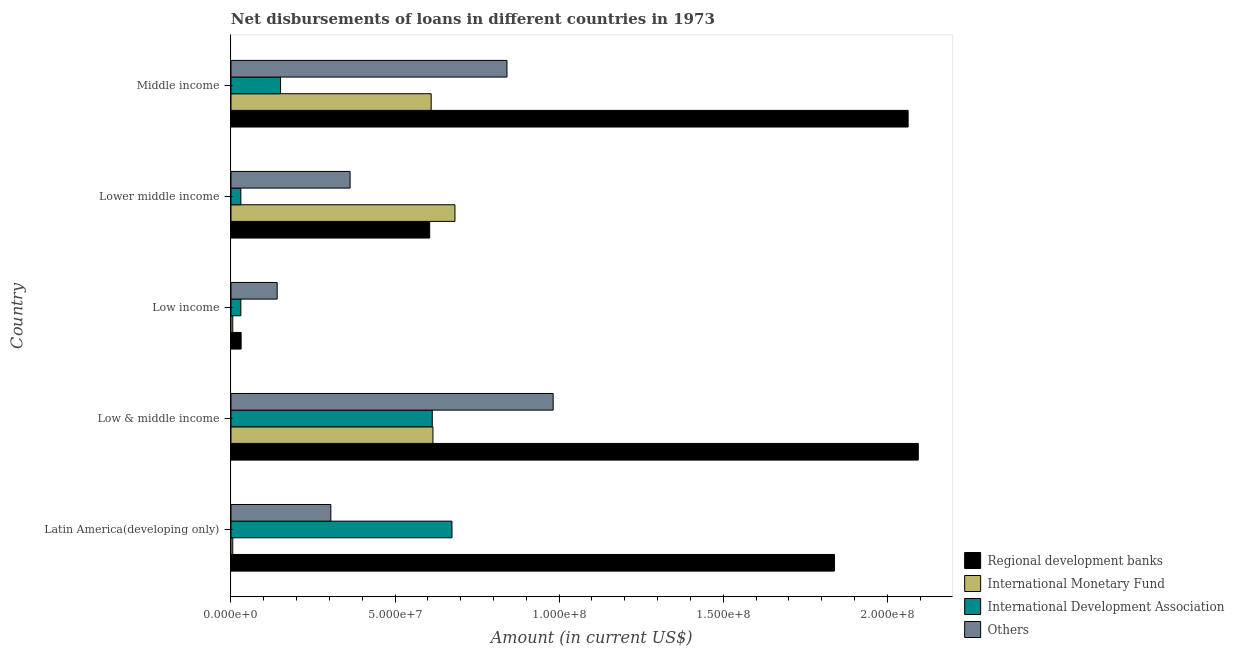How many bars are there on the 4th tick from the bottom?
Keep it short and to the point. 4. In how many cases, is the number of bars for a given country not equal to the number of legend labels?
Offer a terse response. 0. What is the amount of loan disimbursed by other organisations in Middle income?
Keep it short and to the point. 8.41e+07. Across all countries, what is the maximum amount of loan disimbursed by regional development banks?
Offer a very short reply. 2.09e+08. Across all countries, what is the minimum amount of loan disimbursed by other organisations?
Keep it short and to the point. 1.41e+07. In which country was the amount of loan disimbursed by international monetary fund maximum?
Provide a short and direct response. Lower middle income. In which country was the amount of loan disimbursed by international monetary fund minimum?
Ensure brevity in your answer.  Latin America(developing only). What is the total amount of loan disimbursed by regional development banks in the graph?
Make the answer very short. 6.63e+08. What is the difference between the amount of loan disimbursed by other organisations in Low & middle income and that in Middle income?
Your answer should be very brief. 1.41e+07. What is the difference between the amount of loan disimbursed by international development association in Latin America(developing only) and the amount of loan disimbursed by international monetary fund in Lower middle income?
Make the answer very short. -9.13e+05. What is the average amount of loan disimbursed by other organisations per country?
Give a very brief answer. 5.26e+07. What is the difference between the amount of loan disimbursed by regional development banks and amount of loan disimbursed by other organisations in Middle income?
Make the answer very short. 1.22e+08. What is the ratio of the amount of loan disimbursed by other organisations in Latin America(developing only) to that in Middle income?
Offer a terse response. 0.36. What is the difference between the highest and the second highest amount of loan disimbursed by international monetary fund?
Your answer should be very brief. 6.70e+06. What is the difference between the highest and the lowest amount of loan disimbursed by international development association?
Ensure brevity in your answer.  6.43e+07. In how many countries, is the amount of loan disimbursed by international development association greater than the average amount of loan disimbursed by international development association taken over all countries?
Offer a terse response. 2. Is the sum of the amount of loan disimbursed by regional development banks in Low & middle income and Middle income greater than the maximum amount of loan disimbursed by international monetary fund across all countries?
Ensure brevity in your answer.  Yes. What does the 4th bar from the top in Latin America(developing only) represents?
Your response must be concise. Regional development banks. What does the 4th bar from the bottom in Low income represents?
Your answer should be compact. Others. Is it the case that in every country, the sum of the amount of loan disimbursed by regional development banks and amount of loan disimbursed by international monetary fund is greater than the amount of loan disimbursed by international development association?
Your response must be concise. Yes. Are all the bars in the graph horizontal?
Give a very brief answer. Yes. What is the difference between two consecutive major ticks on the X-axis?
Keep it short and to the point. 5.00e+07. Are the values on the major ticks of X-axis written in scientific E-notation?
Provide a short and direct response. Yes. Does the graph contain any zero values?
Provide a succinct answer. No. How many legend labels are there?
Give a very brief answer. 4. How are the legend labels stacked?
Make the answer very short. Vertical. What is the title of the graph?
Offer a terse response. Net disbursements of loans in different countries in 1973. Does "Permanent crop land" appear as one of the legend labels in the graph?
Make the answer very short. No. What is the label or title of the X-axis?
Make the answer very short. Amount (in current US$). What is the Amount (in current US$) of Regional development banks in Latin America(developing only)?
Make the answer very short. 1.84e+08. What is the Amount (in current US$) of International Monetary Fund in Latin America(developing only)?
Keep it short and to the point. 5.46e+05. What is the Amount (in current US$) of International Development Association in Latin America(developing only)?
Your answer should be very brief. 6.73e+07. What is the Amount (in current US$) in Others in Latin America(developing only)?
Make the answer very short. 3.04e+07. What is the Amount (in current US$) in Regional development banks in Low & middle income?
Make the answer very short. 2.09e+08. What is the Amount (in current US$) in International Monetary Fund in Low & middle income?
Your answer should be very brief. 6.16e+07. What is the Amount (in current US$) in International Development Association in Low & middle income?
Make the answer very short. 6.13e+07. What is the Amount (in current US$) in Others in Low & middle income?
Provide a short and direct response. 9.82e+07. What is the Amount (in current US$) of Regional development banks in Low income?
Your answer should be compact. 3.09e+06. What is the Amount (in current US$) in International Monetary Fund in Low income?
Offer a terse response. 5.46e+05. What is the Amount (in current US$) of International Development Association in Low income?
Your answer should be compact. 3.01e+06. What is the Amount (in current US$) of Others in Low income?
Provide a short and direct response. 1.41e+07. What is the Amount (in current US$) of Regional development banks in Lower middle income?
Keep it short and to the point. 6.06e+07. What is the Amount (in current US$) of International Monetary Fund in Lower middle income?
Provide a short and direct response. 6.83e+07. What is the Amount (in current US$) in International Development Association in Lower middle income?
Keep it short and to the point. 3.01e+06. What is the Amount (in current US$) in Others in Lower middle income?
Provide a succinct answer. 3.63e+07. What is the Amount (in current US$) in Regional development banks in Middle income?
Provide a short and direct response. 2.06e+08. What is the Amount (in current US$) in International Monetary Fund in Middle income?
Keep it short and to the point. 6.10e+07. What is the Amount (in current US$) in International Development Association in Middle income?
Your answer should be compact. 1.51e+07. What is the Amount (in current US$) of Others in Middle income?
Your response must be concise. 8.41e+07. Across all countries, what is the maximum Amount (in current US$) of Regional development banks?
Keep it short and to the point. 2.09e+08. Across all countries, what is the maximum Amount (in current US$) of International Monetary Fund?
Provide a short and direct response. 6.83e+07. Across all countries, what is the maximum Amount (in current US$) in International Development Association?
Provide a short and direct response. 6.73e+07. Across all countries, what is the maximum Amount (in current US$) of Others?
Offer a very short reply. 9.82e+07. Across all countries, what is the minimum Amount (in current US$) in Regional development banks?
Offer a very short reply. 3.09e+06. Across all countries, what is the minimum Amount (in current US$) in International Monetary Fund?
Provide a succinct answer. 5.46e+05. Across all countries, what is the minimum Amount (in current US$) of International Development Association?
Your response must be concise. 3.01e+06. Across all countries, what is the minimum Amount (in current US$) of Others?
Keep it short and to the point. 1.41e+07. What is the total Amount (in current US$) in Regional development banks in the graph?
Make the answer very short. 6.63e+08. What is the total Amount (in current US$) in International Monetary Fund in the graph?
Keep it short and to the point. 1.92e+08. What is the total Amount (in current US$) in International Development Association in the graph?
Your answer should be compact. 1.50e+08. What is the total Amount (in current US$) of Others in the graph?
Your response must be concise. 2.63e+08. What is the difference between the Amount (in current US$) in Regional development banks in Latin America(developing only) and that in Low & middle income?
Your response must be concise. -2.55e+07. What is the difference between the Amount (in current US$) in International Monetary Fund in Latin America(developing only) and that in Low & middle income?
Offer a very short reply. -6.10e+07. What is the difference between the Amount (in current US$) of Others in Latin America(developing only) and that in Low & middle income?
Your response must be concise. -6.78e+07. What is the difference between the Amount (in current US$) of Regional development banks in Latin America(developing only) and that in Low income?
Your answer should be compact. 1.81e+08. What is the difference between the Amount (in current US$) of International Development Association in Latin America(developing only) and that in Low income?
Give a very brief answer. 6.43e+07. What is the difference between the Amount (in current US$) of Others in Latin America(developing only) and that in Low income?
Keep it short and to the point. 1.64e+07. What is the difference between the Amount (in current US$) in Regional development banks in Latin America(developing only) and that in Lower middle income?
Your answer should be compact. 1.23e+08. What is the difference between the Amount (in current US$) of International Monetary Fund in Latin America(developing only) and that in Lower middle income?
Your answer should be compact. -6.77e+07. What is the difference between the Amount (in current US$) of International Development Association in Latin America(developing only) and that in Lower middle income?
Your answer should be very brief. 6.43e+07. What is the difference between the Amount (in current US$) in Others in Latin America(developing only) and that in Lower middle income?
Ensure brevity in your answer.  -5.87e+06. What is the difference between the Amount (in current US$) in Regional development banks in Latin America(developing only) and that in Middle income?
Offer a terse response. -2.25e+07. What is the difference between the Amount (in current US$) of International Monetary Fund in Latin America(developing only) and that in Middle income?
Offer a terse response. -6.05e+07. What is the difference between the Amount (in current US$) of International Development Association in Latin America(developing only) and that in Middle income?
Provide a succinct answer. 5.22e+07. What is the difference between the Amount (in current US$) of Others in Latin America(developing only) and that in Middle income?
Offer a terse response. -5.37e+07. What is the difference between the Amount (in current US$) of Regional development banks in Low & middle income and that in Low income?
Your answer should be very brief. 2.06e+08. What is the difference between the Amount (in current US$) of International Monetary Fund in Low & middle income and that in Low income?
Your answer should be compact. 6.10e+07. What is the difference between the Amount (in current US$) of International Development Association in Low & middle income and that in Low income?
Keep it short and to the point. 5.83e+07. What is the difference between the Amount (in current US$) of Others in Low & middle income and that in Low income?
Provide a short and direct response. 8.41e+07. What is the difference between the Amount (in current US$) in Regional development banks in Low & middle income and that in Lower middle income?
Offer a terse response. 1.49e+08. What is the difference between the Amount (in current US$) in International Monetary Fund in Low & middle income and that in Lower middle income?
Make the answer very short. -6.70e+06. What is the difference between the Amount (in current US$) of International Development Association in Low & middle income and that in Lower middle income?
Ensure brevity in your answer.  5.83e+07. What is the difference between the Amount (in current US$) of Others in Low & middle income and that in Lower middle income?
Your response must be concise. 6.19e+07. What is the difference between the Amount (in current US$) in Regional development banks in Low & middle income and that in Middle income?
Offer a terse response. 3.09e+06. What is the difference between the Amount (in current US$) in International Monetary Fund in Low & middle income and that in Middle income?
Give a very brief answer. 5.46e+05. What is the difference between the Amount (in current US$) in International Development Association in Low & middle income and that in Middle income?
Keep it short and to the point. 4.62e+07. What is the difference between the Amount (in current US$) in Others in Low & middle income and that in Middle income?
Provide a succinct answer. 1.41e+07. What is the difference between the Amount (in current US$) of Regional development banks in Low income and that in Lower middle income?
Provide a short and direct response. -5.75e+07. What is the difference between the Amount (in current US$) of International Monetary Fund in Low income and that in Lower middle income?
Provide a succinct answer. -6.77e+07. What is the difference between the Amount (in current US$) of International Development Association in Low income and that in Lower middle income?
Provide a short and direct response. 0. What is the difference between the Amount (in current US$) in Others in Low income and that in Lower middle income?
Provide a succinct answer. -2.22e+07. What is the difference between the Amount (in current US$) in Regional development banks in Low income and that in Middle income?
Ensure brevity in your answer.  -2.03e+08. What is the difference between the Amount (in current US$) in International Monetary Fund in Low income and that in Middle income?
Provide a succinct answer. -6.05e+07. What is the difference between the Amount (in current US$) of International Development Association in Low income and that in Middle income?
Make the answer very short. -1.21e+07. What is the difference between the Amount (in current US$) of Others in Low income and that in Middle income?
Keep it short and to the point. -7.00e+07. What is the difference between the Amount (in current US$) in Regional development banks in Lower middle income and that in Middle income?
Offer a very short reply. -1.46e+08. What is the difference between the Amount (in current US$) in International Monetary Fund in Lower middle income and that in Middle income?
Give a very brief answer. 7.25e+06. What is the difference between the Amount (in current US$) in International Development Association in Lower middle income and that in Middle income?
Keep it short and to the point. -1.21e+07. What is the difference between the Amount (in current US$) in Others in Lower middle income and that in Middle income?
Provide a short and direct response. -4.78e+07. What is the difference between the Amount (in current US$) in Regional development banks in Latin America(developing only) and the Amount (in current US$) in International Monetary Fund in Low & middle income?
Ensure brevity in your answer.  1.22e+08. What is the difference between the Amount (in current US$) of Regional development banks in Latin America(developing only) and the Amount (in current US$) of International Development Association in Low & middle income?
Offer a terse response. 1.23e+08. What is the difference between the Amount (in current US$) of Regional development banks in Latin America(developing only) and the Amount (in current US$) of Others in Low & middle income?
Your response must be concise. 8.57e+07. What is the difference between the Amount (in current US$) of International Monetary Fund in Latin America(developing only) and the Amount (in current US$) of International Development Association in Low & middle income?
Provide a succinct answer. -6.08e+07. What is the difference between the Amount (in current US$) in International Monetary Fund in Latin America(developing only) and the Amount (in current US$) in Others in Low & middle income?
Keep it short and to the point. -9.76e+07. What is the difference between the Amount (in current US$) in International Development Association in Latin America(developing only) and the Amount (in current US$) in Others in Low & middle income?
Ensure brevity in your answer.  -3.08e+07. What is the difference between the Amount (in current US$) in Regional development banks in Latin America(developing only) and the Amount (in current US$) in International Monetary Fund in Low income?
Provide a succinct answer. 1.83e+08. What is the difference between the Amount (in current US$) of Regional development banks in Latin America(developing only) and the Amount (in current US$) of International Development Association in Low income?
Offer a very short reply. 1.81e+08. What is the difference between the Amount (in current US$) of Regional development banks in Latin America(developing only) and the Amount (in current US$) of Others in Low income?
Provide a short and direct response. 1.70e+08. What is the difference between the Amount (in current US$) in International Monetary Fund in Latin America(developing only) and the Amount (in current US$) in International Development Association in Low income?
Ensure brevity in your answer.  -2.46e+06. What is the difference between the Amount (in current US$) in International Monetary Fund in Latin America(developing only) and the Amount (in current US$) in Others in Low income?
Give a very brief answer. -1.35e+07. What is the difference between the Amount (in current US$) in International Development Association in Latin America(developing only) and the Amount (in current US$) in Others in Low income?
Provide a succinct answer. 5.33e+07. What is the difference between the Amount (in current US$) of Regional development banks in Latin America(developing only) and the Amount (in current US$) of International Monetary Fund in Lower middle income?
Offer a terse response. 1.16e+08. What is the difference between the Amount (in current US$) in Regional development banks in Latin America(developing only) and the Amount (in current US$) in International Development Association in Lower middle income?
Make the answer very short. 1.81e+08. What is the difference between the Amount (in current US$) in Regional development banks in Latin America(developing only) and the Amount (in current US$) in Others in Lower middle income?
Offer a very short reply. 1.48e+08. What is the difference between the Amount (in current US$) of International Monetary Fund in Latin America(developing only) and the Amount (in current US$) of International Development Association in Lower middle income?
Ensure brevity in your answer.  -2.46e+06. What is the difference between the Amount (in current US$) in International Monetary Fund in Latin America(developing only) and the Amount (in current US$) in Others in Lower middle income?
Ensure brevity in your answer.  -3.58e+07. What is the difference between the Amount (in current US$) of International Development Association in Latin America(developing only) and the Amount (in current US$) of Others in Lower middle income?
Offer a very short reply. 3.10e+07. What is the difference between the Amount (in current US$) in Regional development banks in Latin America(developing only) and the Amount (in current US$) in International Monetary Fund in Middle income?
Offer a terse response. 1.23e+08. What is the difference between the Amount (in current US$) of Regional development banks in Latin America(developing only) and the Amount (in current US$) of International Development Association in Middle income?
Your response must be concise. 1.69e+08. What is the difference between the Amount (in current US$) of Regional development banks in Latin America(developing only) and the Amount (in current US$) of Others in Middle income?
Make the answer very short. 9.98e+07. What is the difference between the Amount (in current US$) in International Monetary Fund in Latin America(developing only) and the Amount (in current US$) in International Development Association in Middle income?
Provide a short and direct response. -1.46e+07. What is the difference between the Amount (in current US$) of International Monetary Fund in Latin America(developing only) and the Amount (in current US$) of Others in Middle income?
Your answer should be compact. -8.36e+07. What is the difference between the Amount (in current US$) in International Development Association in Latin America(developing only) and the Amount (in current US$) in Others in Middle income?
Your answer should be very brief. -1.68e+07. What is the difference between the Amount (in current US$) of Regional development banks in Low & middle income and the Amount (in current US$) of International Monetary Fund in Low income?
Offer a terse response. 2.09e+08. What is the difference between the Amount (in current US$) of Regional development banks in Low & middle income and the Amount (in current US$) of International Development Association in Low income?
Your answer should be very brief. 2.06e+08. What is the difference between the Amount (in current US$) in Regional development banks in Low & middle income and the Amount (in current US$) in Others in Low income?
Ensure brevity in your answer.  1.95e+08. What is the difference between the Amount (in current US$) in International Monetary Fund in Low & middle income and the Amount (in current US$) in International Development Association in Low income?
Make the answer very short. 5.85e+07. What is the difference between the Amount (in current US$) in International Monetary Fund in Low & middle income and the Amount (in current US$) in Others in Low income?
Your answer should be very brief. 4.75e+07. What is the difference between the Amount (in current US$) in International Development Association in Low & middle income and the Amount (in current US$) in Others in Low income?
Provide a succinct answer. 4.73e+07. What is the difference between the Amount (in current US$) in Regional development banks in Low & middle income and the Amount (in current US$) in International Monetary Fund in Lower middle income?
Provide a succinct answer. 1.41e+08. What is the difference between the Amount (in current US$) in Regional development banks in Low & middle income and the Amount (in current US$) in International Development Association in Lower middle income?
Your answer should be compact. 2.06e+08. What is the difference between the Amount (in current US$) of Regional development banks in Low & middle income and the Amount (in current US$) of Others in Lower middle income?
Offer a very short reply. 1.73e+08. What is the difference between the Amount (in current US$) in International Monetary Fund in Low & middle income and the Amount (in current US$) in International Development Association in Lower middle income?
Offer a terse response. 5.85e+07. What is the difference between the Amount (in current US$) in International Monetary Fund in Low & middle income and the Amount (in current US$) in Others in Lower middle income?
Your response must be concise. 2.53e+07. What is the difference between the Amount (in current US$) in International Development Association in Low & middle income and the Amount (in current US$) in Others in Lower middle income?
Offer a very short reply. 2.50e+07. What is the difference between the Amount (in current US$) of Regional development banks in Low & middle income and the Amount (in current US$) of International Monetary Fund in Middle income?
Give a very brief answer. 1.48e+08. What is the difference between the Amount (in current US$) of Regional development banks in Low & middle income and the Amount (in current US$) of International Development Association in Middle income?
Provide a short and direct response. 1.94e+08. What is the difference between the Amount (in current US$) of Regional development banks in Low & middle income and the Amount (in current US$) of Others in Middle income?
Ensure brevity in your answer.  1.25e+08. What is the difference between the Amount (in current US$) of International Monetary Fund in Low & middle income and the Amount (in current US$) of International Development Association in Middle income?
Your answer should be compact. 4.64e+07. What is the difference between the Amount (in current US$) of International Monetary Fund in Low & middle income and the Amount (in current US$) of Others in Middle income?
Give a very brief answer. -2.26e+07. What is the difference between the Amount (in current US$) in International Development Association in Low & middle income and the Amount (in current US$) in Others in Middle income?
Offer a terse response. -2.28e+07. What is the difference between the Amount (in current US$) in Regional development banks in Low income and the Amount (in current US$) in International Monetary Fund in Lower middle income?
Offer a very short reply. -6.52e+07. What is the difference between the Amount (in current US$) in Regional development banks in Low income and the Amount (in current US$) in International Development Association in Lower middle income?
Make the answer very short. 8.10e+04. What is the difference between the Amount (in current US$) in Regional development banks in Low income and the Amount (in current US$) in Others in Lower middle income?
Offer a very short reply. -3.32e+07. What is the difference between the Amount (in current US$) of International Monetary Fund in Low income and the Amount (in current US$) of International Development Association in Lower middle income?
Offer a very short reply. -2.46e+06. What is the difference between the Amount (in current US$) of International Monetary Fund in Low income and the Amount (in current US$) of Others in Lower middle income?
Your response must be concise. -3.58e+07. What is the difference between the Amount (in current US$) in International Development Association in Low income and the Amount (in current US$) in Others in Lower middle income?
Offer a terse response. -3.33e+07. What is the difference between the Amount (in current US$) in Regional development banks in Low income and the Amount (in current US$) in International Monetary Fund in Middle income?
Provide a short and direct response. -5.79e+07. What is the difference between the Amount (in current US$) in Regional development banks in Low income and the Amount (in current US$) in International Development Association in Middle income?
Offer a very short reply. -1.20e+07. What is the difference between the Amount (in current US$) in Regional development banks in Low income and the Amount (in current US$) in Others in Middle income?
Offer a terse response. -8.10e+07. What is the difference between the Amount (in current US$) of International Monetary Fund in Low income and the Amount (in current US$) of International Development Association in Middle income?
Your response must be concise. -1.46e+07. What is the difference between the Amount (in current US$) in International Monetary Fund in Low income and the Amount (in current US$) in Others in Middle income?
Provide a short and direct response. -8.36e+07. What is the difference between the Amount (in current US$) of International Development Association in Low income and the Amount (in current US$) of Others in Middle income?
Give a very brief answer. -8.11e+07. What is the difference between the Amount (in current US$) in Regional development banks in Lower middle income and the Amount (in current US$) in International Monetary Fund in Middle income?
Keep it short and to the point. -4.45e+05. What is the difference between the Amount (in current US$) in Regional development banks in Lower middle income and the Amount (in current US$) in International Development Association in Middle income?
Make the answer very short. 4.55e+07. What is the difference between the Amount (in current US$) of Regional development banks in Lower middle income and the Amount (in current US$) of Others in Middle income?
Provide a succinct answer. -2.35e+07. What is the difference between the Amount (in current US$) of International Monetary Fund in Lower middle income and the Amount (in current US$) of International Development Association in Middle income?
Ensure brevity in your answer.  5.31e+07. What is the difference between the Amount (in current US$) of International Monetary Fund in Lower middle income and the Amount (in current US$) of Others in Middle income?
Give a very brief answer. -1.58e+07. What is the difference between the Amount (in current US$) of International Development Association in Lower middle income and the Amount (in current US$) of Others in Middle income?
Keep it short and to the point. -8.11e+07. What is the average Amount (in current US$) of Regional development banks per country?
Keep it short and to the point. 1.33e+08. What is the average Amount (in current US$) in International Monetary Fund per country?
Make the answer very short. 3.84e+07. What is the average Amount (in current US$) in International Development Association per country?
Provide a succinct answer. 3.00e+07. What is the average Amount (in current US$) in Others per country?
Ensure brevity in your answer.  5.26e+07. What is the difference between the Amount (in current US$) of Regional development banks and Amount (in current US$) of International Monetary Fund in Latin America(developing only)?
Keep it short and to the point. 1.83e+08. What is the difference between the Amount (in current US$) of Regional development banks and Amount (in current US$) of International Development Association in Latin America(developing only)?
Make the answer very short. 1.17e+08. What is the difference between the Amount (in current US$) of Regional development banks and Amount (in current US$) of Others in Latin America(developing only)?
Give a very brief answer. 1.53e+08. What is the difference between the Amount (in current US$) in International Monetary Fund and Amount (in current US$) in International Development Association in Latin America(developing only)?
Make the answer very short. -6.68e+07. What is the difference between the Amount (in current US$) of International Monetary Fund and Amount (in current US$) of Others in Latin America(developing only)?
Offer a very short reply. -2.99e+07. What is the difference between the Amount (in current US$) in International Development Association and Amount (in current US$) in Others in Latin America(developing only)?
Offer a very short reply. 3.69e+07. What is the difference between the Amount (in current US$) in Regional development banks and Amount (in current US$) in International Monetary Fund in Low & middle income?
Provide a short and direct response. 1.48e+08. What is the difference between the Amount (in current US$) of Regional development banks and Amount (in current US$) of International Development Association in Low & middle income?
Give a very brief answer. 1.48e+08. What is the difference between the Amount (in current US$) in Regional development banks and Amount (in current US$) in Others in Low & middle income?
Keep it short and to the point. 1.11e+08. What is the difference between the Amount (in current US$) of International Monetary Fund and Amount (in current US$) of International Development Association in Low & middle income?
Give a very brief answer. 2.09e+05. What is the difference between the Amount (in current US$) in International Monetary Fund and Amount (in current US$) in Others in Low & middle income?
Ensure brevity in your answer.  -3.66e+07. What is the difference between the Amount (in current US$) of International Development Association and Amount (in current US$) of Others in Low & middle income?
Provide a succinct answer. -3.68e+07. What is the difference between the Amount (in current US$) of Regional development banks and Amount (in current US$) of International Monetary Fund in Low income?
Your response must be concise. 2.54e+06. What is the difference between the Amount (in current US$) of Regional development banks and Amount (in current US$) of International Development Association in Low income?
Your answer should be compact. 8.10e+04. What is the difference between the Amount (in current US$) in Regional development banks and Amount (in current US$) in Others in Low income?
Give a very brief answer. -1.10e+07. What is the difference between the Amount (in current US$) of International Monetary Fund and Amount (in current US$) of International Development Association in Low income?
Your answer should be very brief. -2.46e+06. What is the difference between the Amount (in current US$) of International Monetary Fund and Amount (in current US$) of Others in Low income?
Ensure brevity in your answer.  -1.35e+07. What is the difference between the Amount (in current US$) of International Development Association and Amount (in current US$) of Others in Low income?
Give a very brief answer. -1.11e+07. What is the difference between the Amount (in current US$) in Regional development banks and Amount (in current US$) in International Monetary Fund in Lower middle income?
Your answer should be compact. -7.70e+06. What is the difference between the Amount (in current US$) in Regional development banks and Amount (in current US$) in International Development Association in Lower middle income?
Keep it short and to the point. 5.75e+07. What is the difference between the Amount (in current US$) of Regional development banks and Amount (in current US$) of Others in Lower middle income?
Your response must be concise. 2.43e+07. What is the difference between the Amount (in current US$) of International Monetary Fund and Amount (in current US$) of International Development Association in Lower middle income?
Give a very brief answer. 6.52e+07. What is the difference between the Amount (in current US$) in International Monetary Fund and Amount (in current US$) in Others in Lower middle income?
Keep it short and to the point. 3.20e+07. What is the difference between the Amount (in current US$) of International Development Association and Amount (in current US$) of Others in Lower middle income?
Offer a terse response. -3.33e+07. What is the difference between the Amount (in current US$) of Regional development banks and Amount (in current US$) of International Monetary Fund in Middle income?
Make the answer very short. 1.45e+08. What is the difference between the Amount (in current US$) in Regional development banks and Amount (in current US$) in International Development Association in Middle income?
Make the answer very short. 1.91e+08. What is the difference between the Amount (in current US$) in Regional development banks and Amount (in current US$) in Others in Middle income?
Provide a short and direct response. 1.22e+08. What is the difference between the Amount (in current US$) of International Monetary Fund and Amount (in current US$) of International Development Association in Middle income?
Offer a very short reply. 4.59e+07. What is the difference between the Amount (in current US$) in International Monetary Fund and Amount (in current US$) in Others in Middle income?
Your answer should be very brief. -2.31e+07. What is the difference between the Amount (in current US$) of International Development Association and Amount (in current US$) of Others in Middle income?
Ensure brevity in your answer.  -6.90e+07. What is the ratio of the Amount (in current US$) in Regional development banks in Latin America(developing only) to that in Low & middle income?
Provide a short and direct response. 0.88. What is the ratio of the Amount (in current US$) of International Monetary Fund in Latin America(developing only) to that in Low & middle income?
Provide a succinct answer. 0.01. What is the ratio of the Amount (in current US$) in International Development Association in Latin America(developing only) to that in Low & middle income?
Give a very brief answer. 1.1. What is the ratio of the Amount (in current US$) of Others in Latin America(developing only) to that in Low & middle income?
Your response must be concise. 0.31. What is the ratio of the Amount (in current US$) in Regional development banks in Latin America(developing only) to that in Low income?
Your answer should be very brief. 59.49. What is the ratio of the Amount (in current US$) in International Development Association in Latin America(developing only) to that in Low income?
Give a very brief answer. 22.37. What is the ratio of the Amount (in current US$) of Others in Latin America(developing only) to that in Low income?
Offer a very short reply. 2.16. What is the ratio of the Amount (in current US$) of Regional development banks in Latin America(developing only) to that in Lower middle income?
Your response must be concise. 3.04. What is the ratio of the Amount (in current US$) of International Monetary Fund in Latin America(developing only) to that in Lower middle income?
Offer a very short reply. 0.01. What is the ratio of the Amount (in current US$) of International Development Association in Latin America(developing only) to that in Lower middle income?
Offer a terse response. 22.37. What is the ratio of the Amount (in current US$) in Others in Latin America(developing only) to that in Lower middle income?
Your answer should be compact. 0.84. What is the ratio of the Amount (in current US$) in Regional development banks in Latin America(developing only) to that in Middle income?
Offer a terse response. 0.89. What is the ratio of the Amount (in current US$) of International Monetary Fund in Latin America(developing only) to that in Middle income?
Offer a terse response. 0.01. What is the ratio of the Amount (in current US$) of International Development Association in Latin America(developing only) to that in Middle income?
Your answer should be very brief. 4.46. What is the ratio of the Amount (in current US$) of Others in Latin America(developing only) to that in Middle income?
Provide a succinct answer. 0.36. What is the ratio of the Amount (in current US$) of Regional development banks in Low & middle income to that in Low income?
Keep it short and to the point. 67.76. What is the ratio of the Amount (in current US$) of International Monetary Fund in Low & middle income to that in Low income?
Provide a succinct answer. 112.73. What is the ratio of the Amount (in current US$) of International Development Association in Low & middle income to that in Low income?
Your response must be concise. 20.38. What is the ratio of the Amount (in current US$) of Others in Low & middle income to that in Low income?
Provide a short and direct response. 6.97. What is the ratio of the Amount (in current US$) of Regional development banks in Low & middle income to that in Lower middle income?
Give a very brief answer. 3.46. What is the ratio of the Amount (in current US$) of International Monetary Fund in Low & middle income to that in Lower middle income?
Offer a terse response. 0.9. What is the ratio of the Amount (in current US$) of International Development Association in Low & middle income to that in Lower middle income?
Give a very brief answer. 20.38. What is the ratio of the Amount (in current US$) in Others in Low & middle income to that in Lower middle income?
Your response must be concise. 2.7. What is the ratio of the Amount (in current US$) of Regional development banks in Low & middle income to that in Middle income?
Make the answer very short. 1.01. What is the ratio of the Amount (in current US$) in International Monetary Fund in Low & middle income to that in Middle income?
Make the answer very short. 1.01. What is the ratio of the Amount (in current US$) of International Development Association in Low & middle income to that in Middle income?
Offer a very short reply. 4.06. What is the ratio of the Amount (in current US$) in Others in Low & middle income to that in Middle income?
Offer a very short reply. 1.17. What is the ratio of the Amount (in current US$) of Regional development banks in Low income to that in Lower middle income?
Your answer should be very brief. 0.05. What is the ratio of the Amount (in current US$) in International Monetary Fund in Low income to that in Lower middle income?
Ensure brevity in your answer.  0.01. What is the ratio of the Amount (in current US$) in Others in Low income to that in Lower middle income?
Ensure brevity in your answer.  0.39. What is the ratio of the Amount (in current US$) in Regional development banks in Low income to that in Middle income?
Provide a short and direct response. 0.01. What is the ratio of the Amount (in current US$) in International Monetary Fund in Low income to that in Middle income?
Offer a terse response. 0.01. What is the ratio of the Amount (in current US$) in International Development Association in Low income to that in Middle income?
Your response must be concise. 0.2. What is the ratio of the Amount (in current US$) in Others in Low income to that in Middle income?
Your answer should be compact. 0.17. What is the ratio of the Amount (in current US$) in Regional development banks in Lower middle income to that in Middle income?
Your answer should be very brief. 0.29. What is the ratio of the Amount (in current US$) of International Monetary Fund in Lower middle income to that in Middle income?
Provide a short and direct response. 1.12. What is the ratio of the Amount (in current US$) in International Development Association in Lower middle income to that in Middle income?
Provide a succinct answer. 0.2. What is the ratio of the Amount (in current US$) in Others in Lower middle income to that in Middle income?
Provide a short and direct response. 0.43. What is the difference between the highest and the second highest Amount (in current US$) in Regional development banks?
Keep it short and to the point. 3.09e+06. What is the difference between the highest and the second highest Amount (in current US$) in International Monetary Fund?
Ensure brevity in your answer.  6.70e+06. What is the difference between the highest and the second highest Amount (in current US$) in International Development Association?
Make the answer very short. 6.00e+06. What is the difference between the highest and the second highest Amount (in current US$) of Others?
Offer a terse response. 1.41e+07. What is the difference between the highest and the lowest Amount (in current US$) in Regional development banks?
Make the answer very short. 2.06e+08. What is the difference between the highest and the lowest Amount (in current US$) in International Monetary Fund?
Ensure brevity in your answer.  6.77e+07. What is the difference between the highest and the lowest Amount (in current US$) in International Development Association?
Your response must be concise. 6.43e+07. What is the difference between the highest and the lowest Amount (in current US$) in Others?
Offer a terse response. 8.41e+07. 